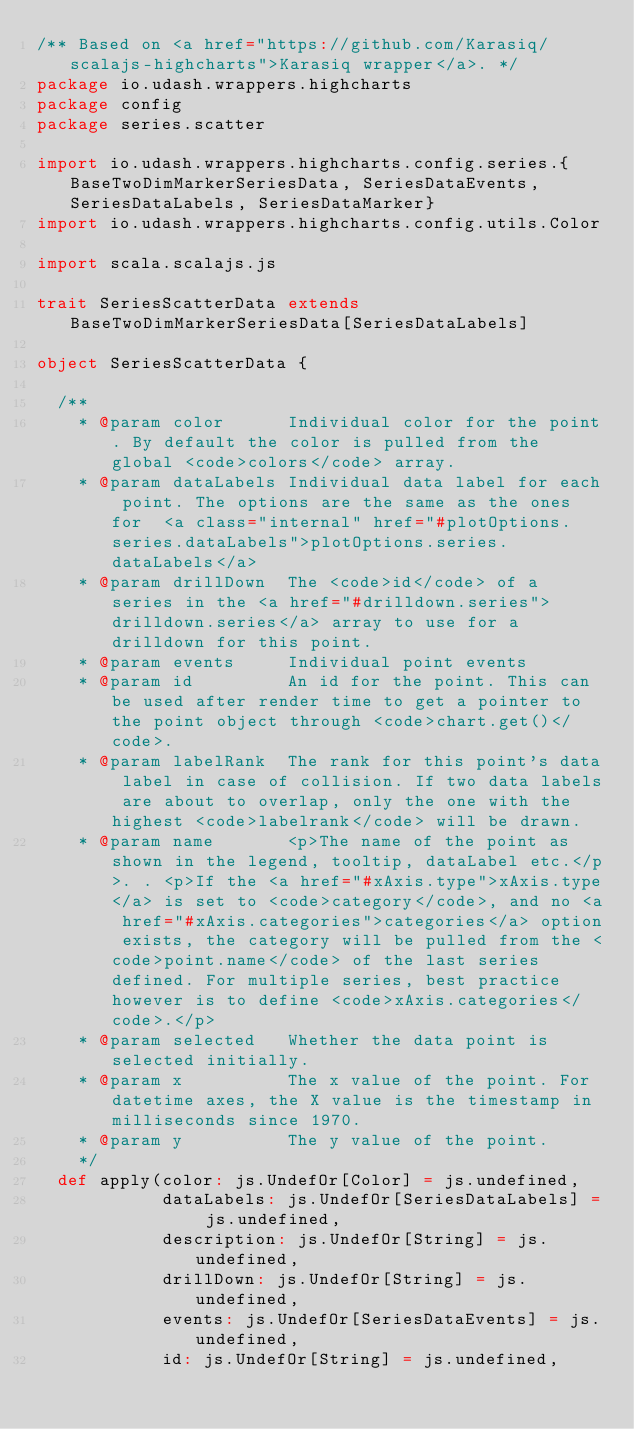<code> <loc_0><loc_0><loc_500><loc_500><_Scala_>/** Based on <a href="https://github.com/Karasiq/scalajs-highcharts">Karasiq wrapper</a>. */
package io.udash.wrappers.highcharts
package config
package series.scatter

import io.udash.wrappers.highcharts.config.series.{BaseTwoDimMarkerSeriesData, SeriesDataEvents, SeriesDataLabels, SeriesDataMarker}
import io.udash.wrappers.highcharts.config.utils.Color

import scala.scalajs.js

trait SeriesScatterData extends BaseTwoDimMarkerSeriesData[SeriesDataLabels]

object SeriesScatterData {

  /**
    * @param color      Individual color for the point. By default the color is pulled from the global <code>colors</code> array.
    * @param dataLabels Individual data label for each point. The options are the same as the ones for  <a class="internal" href="#plotOptions.series.dataLabels">plotOptions.series.dataLabels</a>
    * @param drillDown  The <code>id</code> of a series in the <a href="#drilldown.series">drilldown.series</a> array to use for a drilldown for this point.
    * @param events     Individual point events
    * @param id         An id for the point. This can be used after render time to get a pointer to the point object through <code>chart.get()</code>.
    * @param labelRank  The rank for this point's data label in case of collision. If two data labels are about to overlap, only the one with the highest <code>labelrank</code> will be drawn.
    * @param name       <p>The name of the point as shown in the legend, tooltip, dataLabel etc.</p>. . <p>If the <a href="#xAxis.type">xAxis.type</a> is set to <code>category</code>, and no <a href="#xAxis.categories">categories</a> option exists, the category will be pulled from the <code>point.name</code> of the last series defined. For multiple series, best practice however is to define <code>xAxis.categories</code>.</p>
    * @param selected   Whether the data point is selected initially.
    * @param x          The x value of the point. For datetime axes, the X value is the timestamp in milliseconds since 1970.
    * @param y          The y value of the point.
    */
  def apply(color: js.UndefOr[Color] = js.undefined,
            dataLabels: js.UndefOr[SeriesDataLabels] = js.undefined,
            description: js.UndefOr[String] = js.undefined,
            drillDown: js.UndefOr[String] = js.undefined,
            events: js.UndefOr[SeriesDataEvents] = js.undefined,
            id: js.UndefOr[String] = js.undefined,</code> 